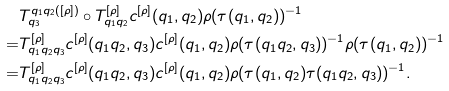Convert formula to latex. <formula><loc_0><loc_0><loc_500><loc_500>& T ^ { q _ { 1 } q _ { 2 } ( [ \rho ] ) } _ { q _ { 3 } } \circ T ^ { [ \rho ] } _ { q _ { 1 } q _ { 2 } } c ^ { [ \rho ] } ( q _ { 1 } , q _ { 2 } ) \rho ( \tau ( q _ { 1 } , q _ { 2 } ) ) ^ { - 1 } \\ = & T ^ { [ \rho ] } _ { q _ { 1 } q _ { 2 } q _ { 3 } } c ^ { [ \rho ] } ( q _ { 1 } q _ { 2 } , q _ { 3 } ) c ^ { [ \rho ] } ( q _ { 1 } , q _ { 2 } ) \rho ( \tau ( q _ { 1 } q _ { 2 } , q _ { 3 } ) ) ^ { - 1 } \rho ( \tau ( q _ { 1 } , q _ { 2 } ) ) ^ { - 1 } \\ = & T ^ { [ \rho ] } _ { q _ { 1 } q _ { 2 } q _ { 3 } } c ^ { [ \rho ] } ( q _ { 1 } q _ { 2 } , q _ { 3 } ) c ^ { [ \rho ] } ( q _ { 1 } , q _ { 2 } ) \rho ( \tau ( q _ { 1 } , q _ { 2 } ) \tau ( q _ { 1 } q _ { 2 } , q _ { 3 } ) ) ^ { - 1 } .</formula> 